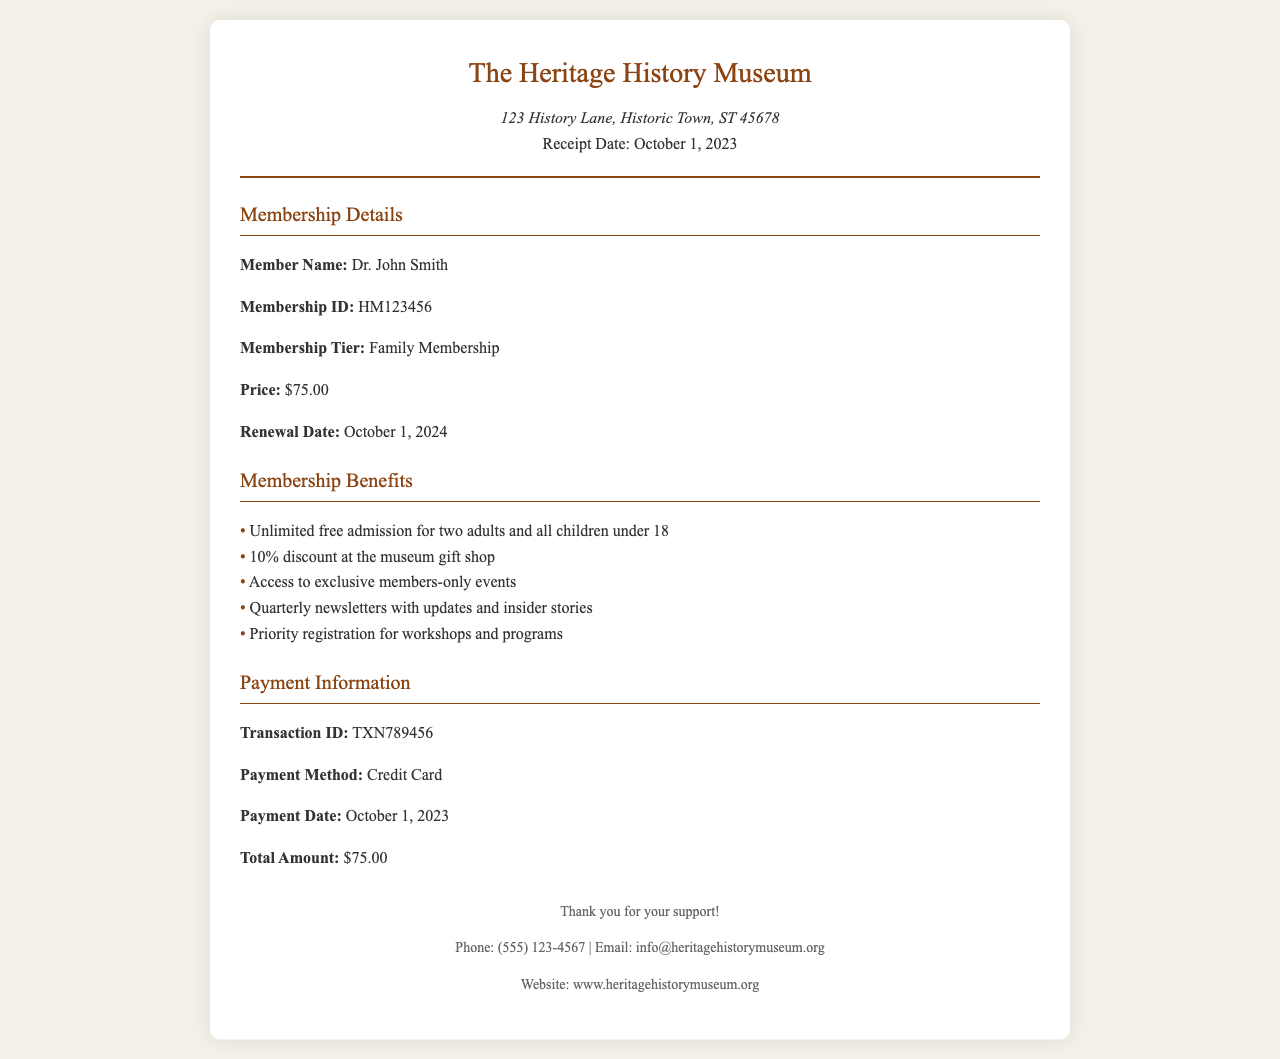What is the name of the museum? The museum's name is prominently featured at the top of the document.
Answer: The Heritage History Museum What is the member's name? The member's name is listed under the Membership Details section.
Answer: Dr. John Smith What is the membership tier? The membership tier is specified in the Membership Details section.
Answer: Family Membership What is the renewal date of the membership? The renewal date is clearly stated in the Membership Details section.
Answer: October 1, 2024 What is the total amount paid for the membership? The total amount paid is shown in the Payment Information section.
Answer: $75.00 How many adults can enter the museum for free with this membership? The benefits clearly state how many adults can enjoy free admission.
Answer: Two adults What is the discount percentage at the museum gift shop for members? This information is provided in the Membership Benefits section.
Answer: 10% What is the transaction ID for the payment? The transaction ID is listed in the Payment Information section of the document.
Answer: TXN789456 What is the payment method used? The payment method is specified in the Payment Information section.
Answer: Credit Card 